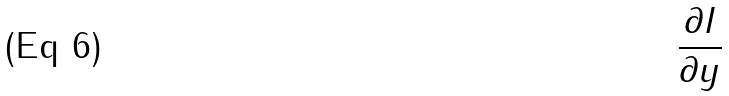Convert formula to latex. <formula><loc_0><loc_0><loc_500><loc_500>\frac { \partial I } { \partial y }</formula> 